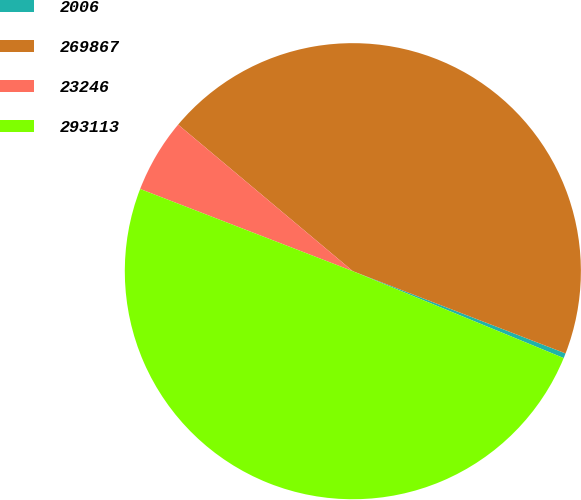<chart> <loc_0><loc_0><loc_500><loc_500><pie_chart><fcel>2006<fcel>269867<fcel>23246<fcel>293113<nl><fcel>0.35%<fcel>44.76%<fcel>5.24%<fcel>49.65%<nl></chart> 